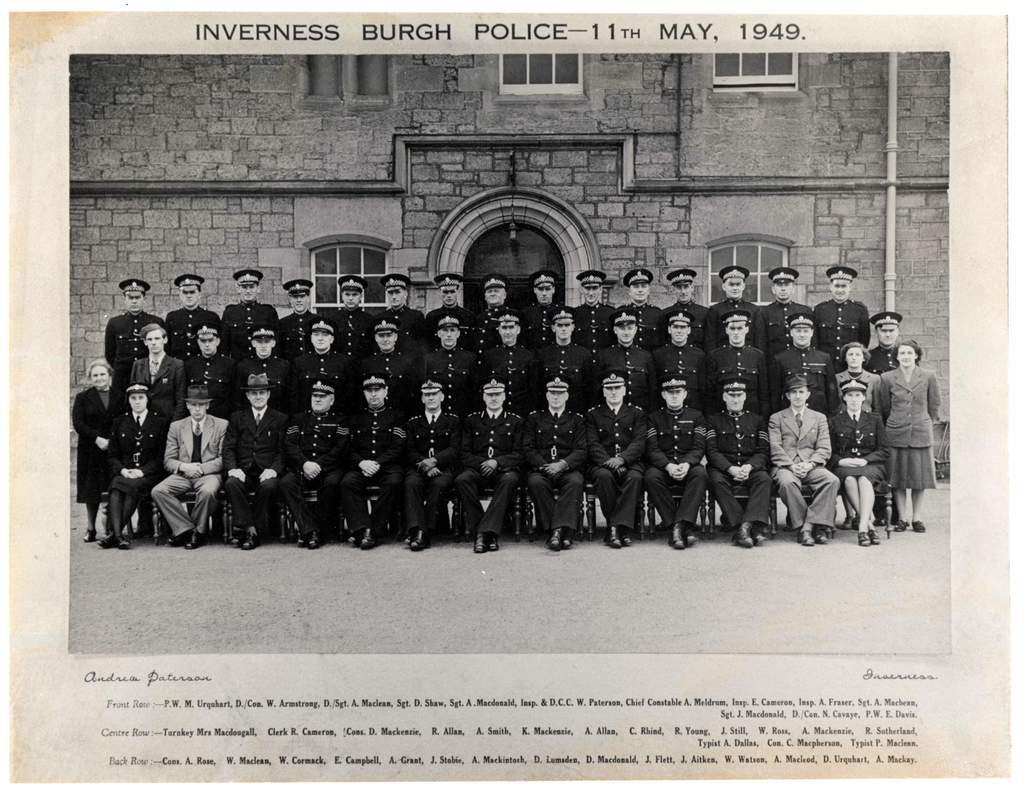In one or two sentences, can you explain what this image depicts? In the image we can see the photograph of the people sitting and standing, they are wearing clothes, shoes and caps. Here we can see the building and the windows of the building and the text. 